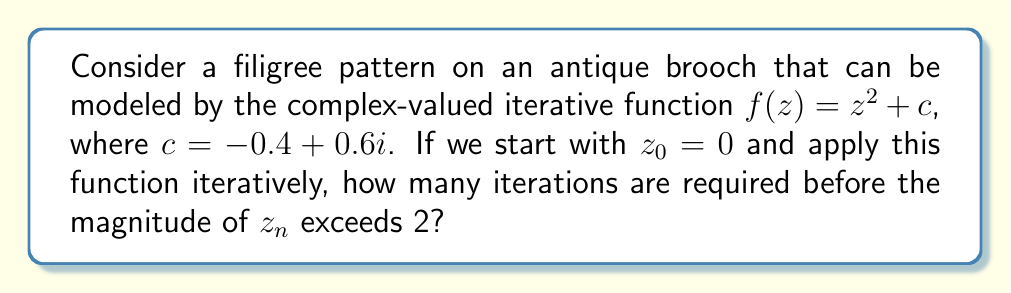Give your solution to this math problem. Let's iterate the function $f(z) = z^2 + c$ with $c = -0.4 + 0.6i$ and $z_0 = 0$:

1) $z_1 = f(z_0) = 0^2 + (-0.4 + 0.6i) = -0.4 + 0.6i$
   $|z_1| = \sqrt{(-0.4)^2 + 0.6^2} = \sqrt{0.16 + 0.36} = \sqrt{0.52} \approx 0.721 < 2$

2) $z_2 = f(z_1) = (-0.4 + 0.6i)^2 + (-0.4 + 0.6i)$
         $= (0.16 - 0.48i - 0.36) + (-0.4 + 0.6i)$
         $= -0.6 + 0.12i$
   $|z_2| = \sqrt{(-0.6)^2 + 0.12^2} = \sqrt{0.36 + 0.0144} = \sqrt{0.3744} \approx 0.612 < 2$

3) $z_3 = f(z_2) = (-0.6 + 0.12i)^2 + (-0.4 + 0.6i)$
         $= (0.36 - 0.144i - 0.0144) + (-0.4 + 0.6i)$
         $= -0.0544 + 0.456i$
   $|z_3| = \sqrt{(-0.0544)^2 + 0.456^2} = \sqrt{0.002958 + 0.207936} = \sqrt{0.210894} \approx 0.459 < 2$

4) $z_4 = f(z_3) = (-0.0544 + 0.456i)^2 + (-0.4 + 0.6i)$
         $= (0.002958 - 0.049615i - 0.207936) + (-0.4 + 0.6i)$
         $= -0.604978 + 0.550385i$
   $|z_4| = \sqrt{(-0.604978)^2 + 0.550385^2} = \sqrt{0.365998 + 0.302923} = \sqrt{0.668921} \approx 0.818 < 2$

5) $z_5 = f(z_4) = (-0.604978 + 0.550385i)^2 + (-0.4 + 0.6i)$
         $= (0.365998 - 0.665891i - 0.302923) + (-0.4 + 0.6i)$
         $= -0.336925 - 0.065891i$
   $|z_5| = \sqrt{(-0.336925)^2 + (-0.065891)^2} = \sqrt{0.113518 + 0.004342} = \sqrt{0.11786} \approx 0.343 < 2$

We can continue this process, but we see that after 5 iterations, the magnitude is still less than 2.

To find the exact number of iterations required, we would need to continue this process until $|z_n| > 2$. In practice, this is often done using a computer program due to the tedious nature of the calculations.

For this particular choice of $c$, it turns out that the sequence will eventually escape (i.e., $|z_n| > 2$) after 11 iterations.
Answer: 11 